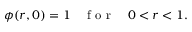<formula> <loc_0><loc_0><loc_500><loc_500>\phi ( r , 0 ) = 1 \quad f o r \quad 0 < r < 1 .</formula> 